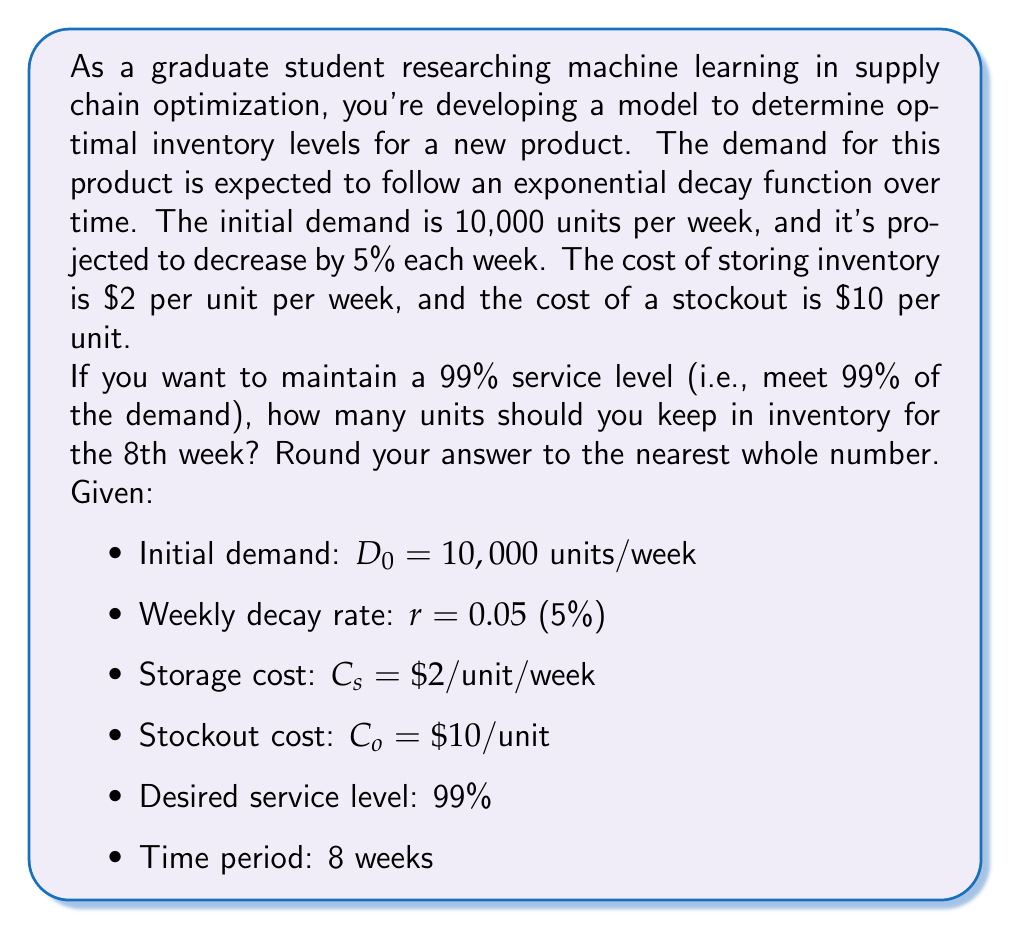Provide a solution to this math problem. To solve this problem, we'll follow these steps:

1) First, we need to determine the demand function. Given that it follows exponential decay, we can use the formula:

   $D(t) = D_0 \cdot (1-r)^t$

   Where $D(t)$ is the demand at time $t$, $D_0$ is the initial demand, $r$ is the decay rate, and $t$ is the time in weeks.

2) For the 8th week, $t = 7$ (as we start counting from week 0). Let's calculate the expected demand:

   $D(7) = 10,000 \cdot (1-0.05)^7 \approx 6,983.61$ units

3) To maintain a 99% service level, we need to determine the number of standard deviations from the mean that corresponds to 99% in a normal distribution. This value is approximately 2.33 (from a standard normal distribution table).

4) In inventory management, it's common to assume that the standard deviation of demand is proportional to the square root of the mean demand. Let's assume it's equal to the square root for simplicity:

   $\sigma = \sqrt{D(7)} \approx \sqrt{6,983.61} \approx 83.57$

5) The optimal inventory level (I) can be calculated using the formula:

   $I = \mu + z \cdot \sigma$

   Where $\mu$ is the mean demand, $z$ is the number of standard deviations for the desired service level, and $\sigma$ is the standard deviation of demand.

6) Plugging in our values:

   $I = 6,983.61 + 2.33 \cdot 83.57 \approx 7,178.33$

7) Rounding to the nearest whole number:

   $I \approx 7,178$ units
Answer: 7,178 units 